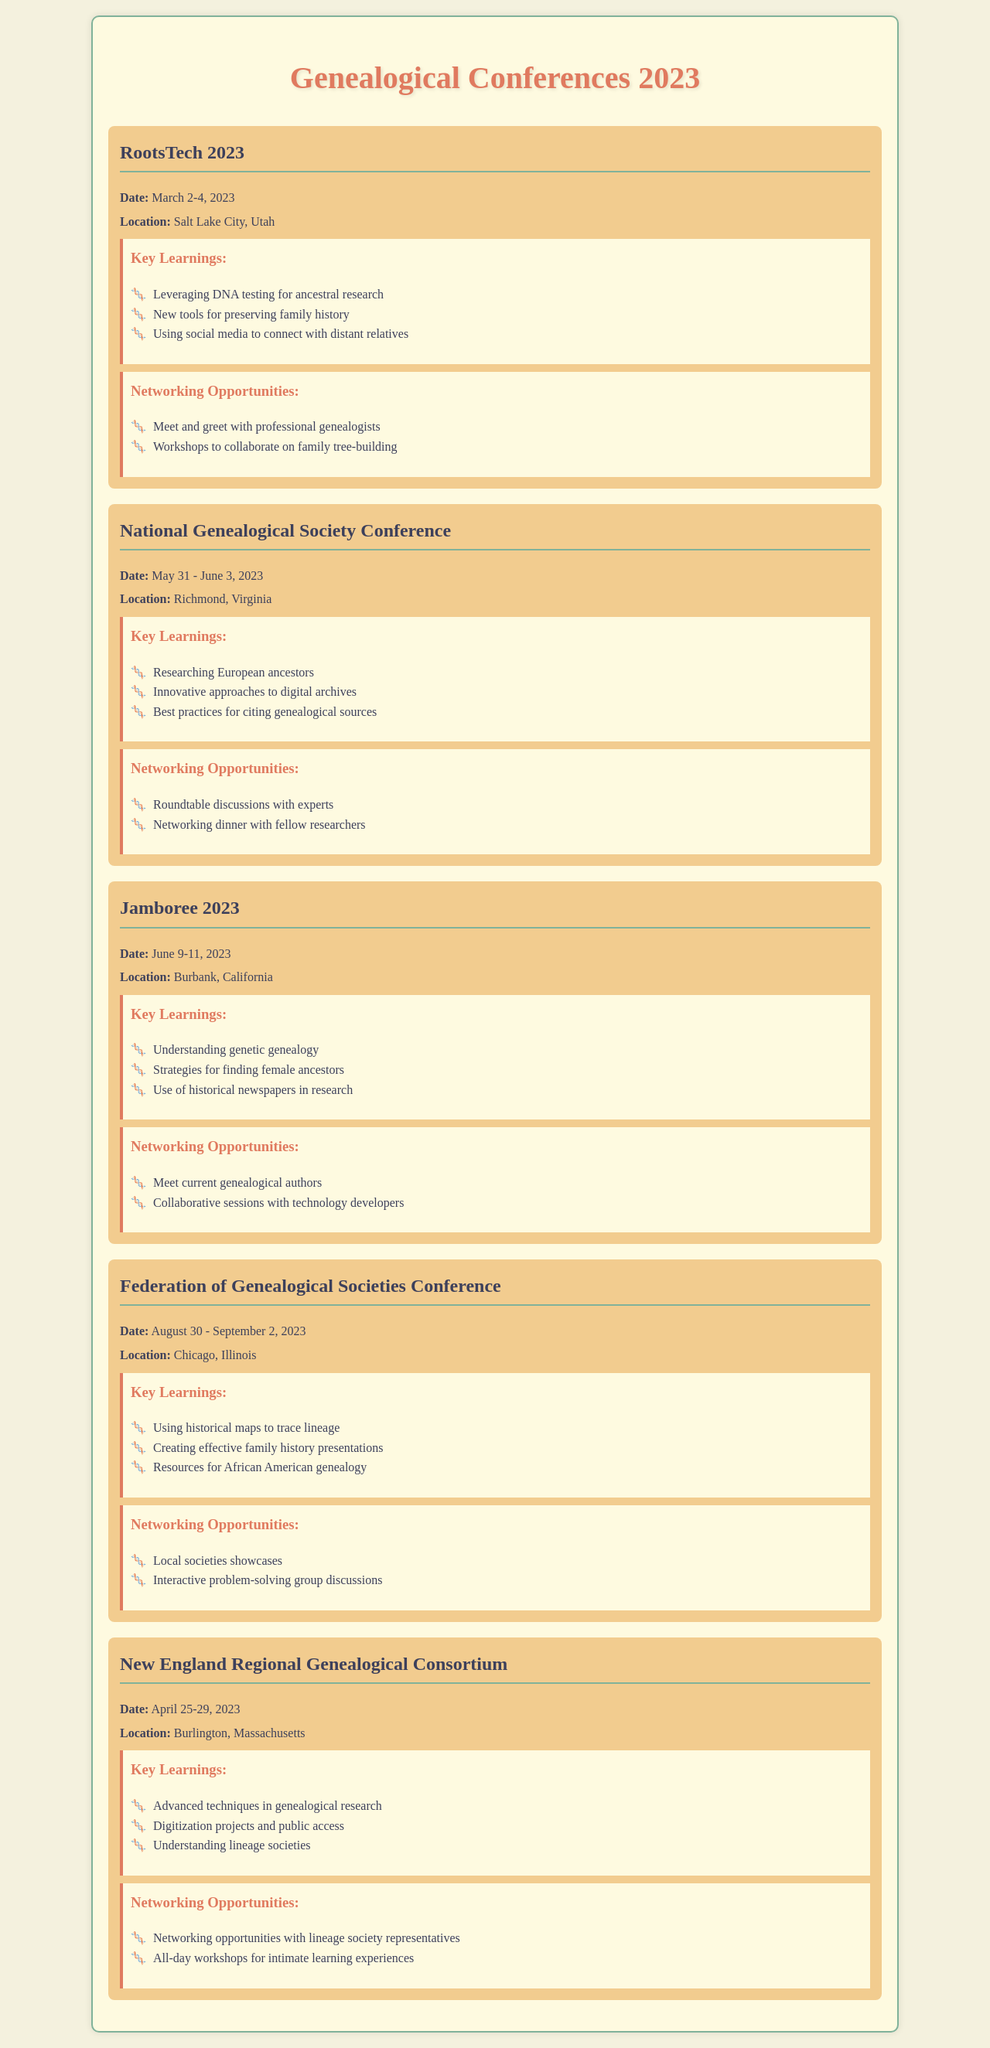What is the date of RootsTech 2023? The date for RootsTech 2023 is mentioned in the document as March 2-4, 2023.
Answer: March 2-4, 2023 Where was the National Genealogical Society Conference held? The location of the National Genealogical Society Conference is given as Richmond, Virginia.
Answer: Richmond, Virginia What is one key learning from Jamboree 2023? The key learnings for Jamboree 2023 include strategies for finding female ancestors.
Answer: Strategies for finding female ancestors How many days did the Federation of Genealogical Societies Conference last? The duration of the Federation of Genealogical Societies Conference is indicated as four days from August 30 to September 2, 2023.
Answer: Four days Which conference included workshops to collaborate on family tree-building? The conference that included workshops for collaboration on family tree-building is RootsTech 2023.
Answer: RootsTech 2023 What specific type of genealogy resources was highlighted at the Federation of Genealogical Societies Conference? The resources highlighted at this conference pertain to African American genealogy.
Answer: Resources for African American genealogy What is the main focus of the New England Regional Genealogical Consortium's key learnings? The key learnings cover advanced techniques in genealogical research as a main focus.
Answer: Advanced techniques in genealogical research Which conference offered networking opportunities with lineage society representatives? The New England Regional Genealogical Consortium offered networking with lineage society representatives.
Answer: New England Regional Genealogical Consortium 